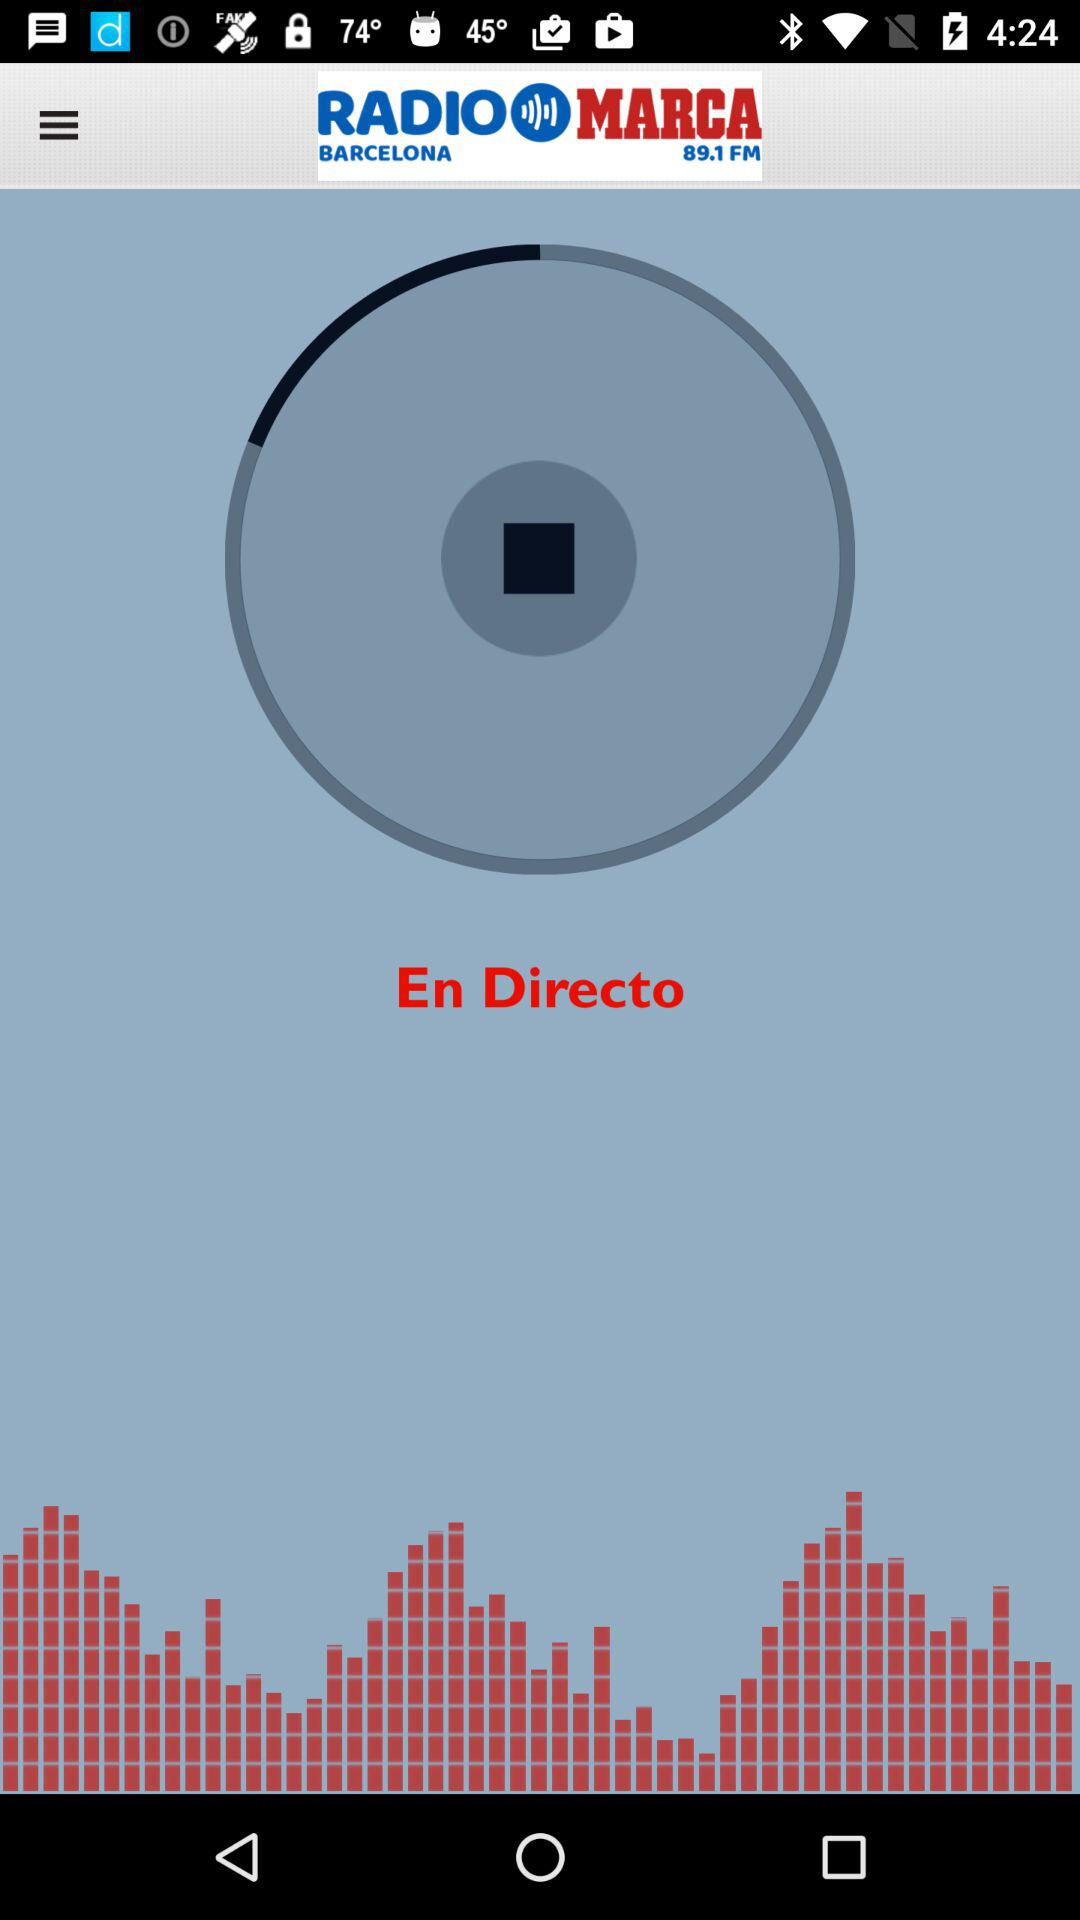What station was given? The given station was "RADIO MARCA BARCELONA 89.1 FM". 